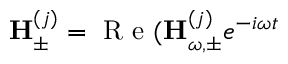Convert formula to latex. <formula><loc_0><loc_0><loc_500><loc_500>{ H } _ { \pm } ^ { ( j ) } = R e ( { H } _ { \omega , \pm } ^ { ( j ) } e ^ { - i \omega t }</formula> 